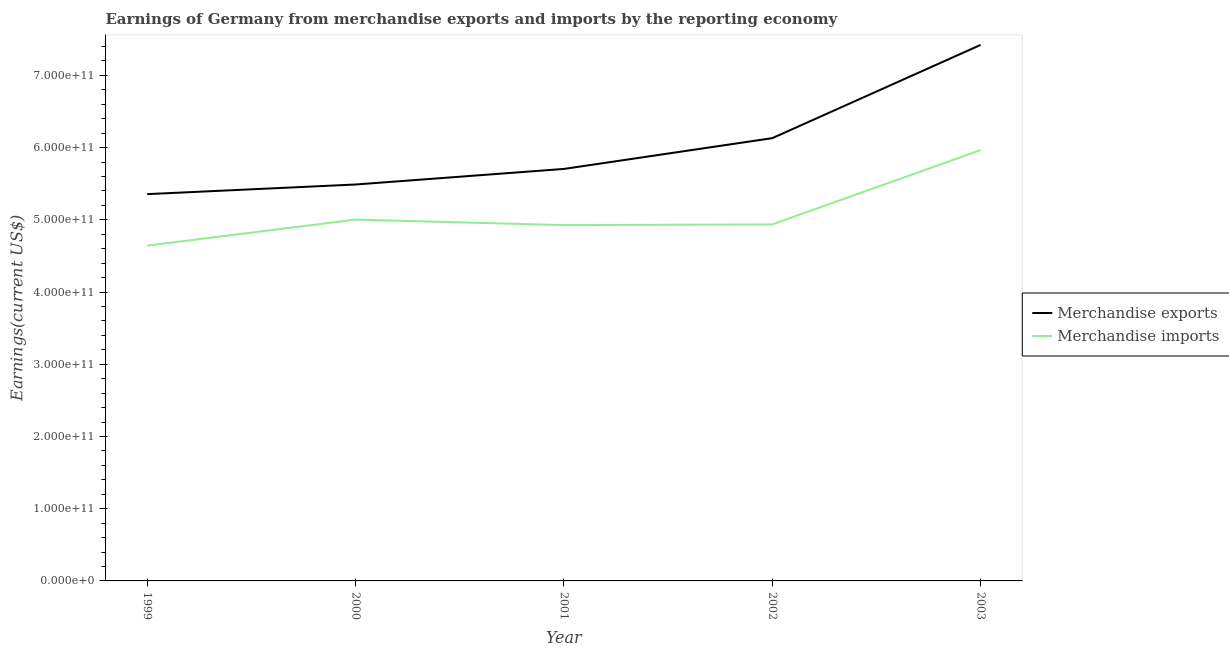Does the line corresponding to earnings from merchandise exports intersect with the line corresponding to earnings from merchandise imports?
Your answer should be compact. No. What is the earnings from merchandise exports in 2003?
Ensure brevity in your answer.  7.42e+11. Across all years, what is the maximum earnings from merchandise imports?
Provide a short and direct response. 5.96e+11. Across all years, what is the minimum earnings from merchandise exports?
Offer a very short reply. 5.36e+11. In which year was the earnings from merchandise exports maximum?
Your answer should be very brief. 2003. What is the total earnings from merchandise exports in the graph?
Your answer should be compact. 3.01e+12. What is the difference between the earnings from merchandise imports in 1999 and that in 2000?
Make the answer very short. -3.60e+1. What is the difference between the earnings from merchandise exports in 2002 and the earnings from merchandise imports in 2000?
Your response must be concise. 1.13e+11. What is the average earnings from merchandise exports per year?
Provide a succinct answer. 6.02e+11. In the year 2001, what is the difference between the earnings from merchandise imports and earnings from merchandise exports?
Your answer should be very brief. -7.78e+1. In how many years, is the earnings from merchandise imports greater than 520000000000 US$?
Your response must be concise. 1. What is the ratio of the earnings from merchandise imports in 2002 to that in 2003?
Your response must be concise. 0.83. Is the earnings from merchandise exports in 1999 less than that in 2002?
Your answer should be compact. Yes. Is the difference between the earnings from merchandise exports in 2000 and 2001 greater than the difference between the earnings from merchandise imports in 2000 and 2001?
Your answer should be compact. No. What is the difference between the highest and the second highest earnings from merchandise exports?
Offer a very short reply. 1.29e+11. What is the difference between the highest and the lowest earnings from merchandise imports?
Keep it short and to the point. 1.32e+11. How many lines are there?
Your answer should be compact. 2. How many years are there in the graph?
Your response must be concise. 5. What is the difference between two consecutive major ticks on the Y-axis?
Your answer should be very brief. 1.00e+11. Does the graph contain any zero values?
Ensure brevity in your answer.  No. Does the graph contain grids?
Ensure brevity in your answer.  No. Where does the legend appear in the graph?
Your answer should be compact. Center right. How are the legend labels stacked?
Your response must be concise. Vertical. What is the title of the graph?
Provide a short and direct response. Earnings of Germany from merchandise exports and imports by the reporting economy. What is the label or title of the X-axis?
Offer a terse response. Year. What is the label or title of the Y-axis?
Ensure brevity in your answer.  Earnings(current US$). What is the Earnings(current US$) in Merchandise exports in 1999?
Ensure brevity in your answer.  5.36e+11. What is the Earnings(current US$) of Merchandise imports in 1999?
Offer a terse response. 4.64e+11. What is the Earnings(current US$) of Merchandise exports in 2000?
Make the answer very short. 5.49e+11. What is the Earnings(current US$) in Merchandise imports in 2000?
Your answer should be very brief. 5.00e+11. What is the Earnings(current US$) of Merchandise exports in 2001?
Offer a very short reply. 5.70e+11. What is the Earnings(current US$) in Merchandise imports in 2001?
Provide a short and direct response. 4.93e+11. What is the Earnings(current US$) in Merchandise exports in 2002?
Your answer should be compact. 6.13e+11. What is the Earnings(current US$) of Merchandise imports in 2002?
Offer a very short reply. 4.94e+11. What is the Earnings(current US$) of Merchandise exports in 2003?
Provide a short and direct response. 7.42e+11. What is the Earnings(current US$) of Merchandise imports in 2003?
Provide a succinct answer. 5.96e+11. Across all years, what is the maximum Earnings(current US$) in Merchandise exports?
Offer a very short reply. 7.42e+11. Across all years, what is the maximum Earnings(current US$) in Merchandise imports?
Ensure brevity in your answer.  5.96e+11. Across all years, what is the minimum Earnings(current US$) of Merchandise exports?
Your answer should be compact. 5.36e+11. Across all years, what is the minimum Earnings(current US$) in Merchandise imports?
Offer a very short reply. 4.64e+11. What is the total Earnings(current US$) of Merchandise exports in the graph?
Provide a short and direct response. 3.01e+12. What is the total Earnings(current US$) in Merchandise imports in the graph?
Give a very brief answer. 2.55e+12. What is the difference between the Earnings(current US$) in Merchandise exports in 1999 and that in 2000?
Your answer should be very brief. -1.33e+1. What is the difference between the Earnings(current US$) in Merchandise imports in 1999 and that in 2000?
Keep it short and to the point. -3.60e+1. What is the difference between the Earnings(current US$) of Merchandise exports in 1999 and that in 2001?
Your answer should be very brief. -3.49e+1. What is the difference between the Earnings(current US$) in Merchandise imports in 1999 and that in 2001?
Ensure brevity in your answer.  -2.84e+1. What is the difference between the Earnings(current US$) of Merchandise exports in 1999 and that in 2002?
Give a very brief answer. -7.75e+1. What is the difference between the Earnings(current US$) in Merchandise imports in 1999 and that in 2002?
Your answer should be very brief. -2.94e+1. What is the difference between the Earnings(current US$) in Merchandise exports in 1999 and that in 2003?
Keep it short and to the point. -2.07e+11. What is the difference between the Earnings(current US$) of Merchandise imports in 1999 and that in 2003?
Give a very brief answer. -1.32e+11. What is the difference between the Earnings(current US$) in Merchandise exports in 2000 and that in 2001?
Offer a very short reply. -2.16e+1. What is the difference between the Earnings(current US$) in Merchandise imports in 2000 and that in 2001?
Your answer should be compact. 7.62e+09. What is the difference between the Earnings(current US$) of Merchandise exports in 2000 and that in 2002?
Your answer should be very brief. -6.42e+1. What is the difference between the Earnings(current US$) in Merchandise imports in 2000 and that in 2002?
Provide a short and direct response. 6.64e+09. What is the difference between the Earnings(current US$) in Merchandise exports in 2000 and that in 2003?
Provide a succinct answer. -1.93e+11. What is the difference between the Earnings(current US$) of Merchandise imports in 2000 and that in 2003?
Provide a succinct answer. -9.62e+1. What is the difference between the Earnings(current US$) in Merchandise exports in 2001 and that in 2002?
Your answer should be compact. -4.26e+1. What is the difference between the Earnings(current US$) of Merchandise imports in 2001 and that in 2002?
Offer a terse response. -9.79e+08. What is the difference between the Earnings(current US$) in Merchandise exports in 2001 and that in 2003?
Provide a succinct answer. -1.72e+11. What is the difference between the Earnings(current US$) in Merchandise imports in 2001 and that in 2003?
Give a very brief answer. -1.04e+11. What is the difference between the Earnings(current US$) of Merchandise exports in 2002 and that in 2003?
Offer a very short reply. -1.29e+11. What is the difference between the Earnings(current US$) of Merchandise imports in 2002 and that in 2003?
Offer a terse response. -1.03e+11. What is the difference between the Earnings(current US$) of Merchandise exports in 1999 and the Earnings(current US$) of Merchandise imports in 2000?
Provide a short and direct response. 3.53e+1. What is the difference between the Earnings(current US$) in Merchandise exports in 1999 and the Earnings(current US$) in Merchandise imports in 2001?
Your answer should be very brief. 4.29e+1. What is the difference between the Earnings(current US$) in Merchandise exports in 1999 and the Earnings(current US$) in Merchandise imports in 2002?
Offer a very short reply. 4.19e+1. What is the difference between the Earnings(current US$) of Merchandise exports in 1999 and the Earnings(current US$) of Merchandise imports in 2003?
Ensure brevity in your answer.  -6.09e+1. What is the difference between the Earnings(current US$) in Merchandise exports in 2000 and the Earnings(current US$) in Merchandise imports in 2001?
Your response must be concise. 5.62e+1. What is the difference between the Earnings(current US$) of Merchandise exports in 2000 and the Earnings(current US$) of Merchandise imports in 2002?
Your response must be concise. 5.53e+1. What is the difference between the Earnings(current US$) in Merchandise exports in 2000 and the Earnings(current US$) in Merchandise imports in 2003?
Provide a short and direct response. -4.76e+1. What is the difference between the Earnings(current US$) of Merchandise exports in 2001 and the Earnings(current US$) of Merchandise imports in 2002?
Offer a very short reply. 7.68e+1. What is the difference between the Earnings(current US$) of Merchandise exports in 2001 and the Earnings(current US$) of Merchandise imports in 2003?
Offer a terse response. -2.60e+1. What is the difference between the Earnings(current US$) in Merchandise exports in 2002 and the Earnings(current US$) in Merchandise imports in 2003?
Offer a terse response. 1.66e+1. What is the average Earnings(current US$) of Merchandise exports per year?
Ensure brevity in your answer.  6.02e+11. What is the average Earnings(current US$) in Merchandise imports per year?
Offer a terse response. 5.09e+11. In the year 1999, what is the difference between the Earnings(current US$) in Merchandise exports and Earnings(current US$) in Merchandise imports?
Offer a very short reply. 7.13e+1. In the year 2000, what is the difference between the Earnings(current US$) of Merchandise exports and Earnings(current US$) of Merchandise imports?
Your answer should be compact. 4.86e+1. In the year 2001, what is the difference between the Earnings(current US$) in Merchandise exports and Earnings(current US$) in Merchandise imports?
Provide a succinct answer. 7.78e+1. In the year 2002, what is the difference between the Earnings(current US$) of Merchandise exports and Earnings(current US$) of Merchandise imports?
Ensure brevity in your answer.  1.19e+11. In the year 2003, what is the difference between the Earnings(current US$) in Merchandise exports and Earnings(current US$) in Merchandise imports?
Make the answer very short. 1.46e+11. What is the ratio of the Earnings(current US$) in Merchandise exports in 1999 to that in 2000?
Keep it short and to the point. 0.98. What is the ratio of the Earnings(current US$) in Merchandise imports in 1999 to that in 2000?
Your answer should be compact. 0.93. What is the ratio of the Earnings(current US$) of Merchandise exports in 1999 to that in 2001?
Your response must be concise. 0.94. What is the ratio of the Earnings(current US$) in Merchandise imports in 1999 to that in 2001?
Ensure brevity in your answer.  0.94. What is the ratio of the Earnings(current US$) of Merchandise exports in 1999 to that in 2002?
Keep it short and to the point. 0.87. What is the ratio of the Earnings(current US$) in Merchandise imports in 1999 to that in 2002?
Make the answer very short. 0.94. What is the ratio of the Earnings(current US$) of Merchandise exports in 1999 to that in 2003?
Give a very brief answer. 0.72. What is the ratio of the Earnings(current US$) of Merchandise imports in 1999 to that in 2003?
Offer a very short reply. 0.78. What is the ratio of the Earnings(current US$) of Merchandise exports in 2000 to that in 2001?
Ensure brevity in your answer.  0.96. What is the ratio of the Earnings(current US$) of Merchandise imports in 2000 to that in 2001?
Ensure brevity in your answer.  1.02. What is the ratio of the Earnings(current US$) in Merchandise exports in 2000 to that in 2002?
Ensure brevity in your answer.  0.9. What is the ratio of the Earnings(current US$) in Merchandise imports in 2000 to that in 2002?
Provide a succinct answer. 1.01. What is the ratio of the Earnings(current US$) in Merchandise exports in 2000 to that in 2003?
Offer a terse response. 0.74. What is the ratio of the Earnings(current US$) of Merchandise imports in 2000 to that in 2003?
Your answer should be very brief. 0.84. What is the ratio of the Earnings(current US$) in Merchandise exports in 2001 to that in 2002?
Provide a short and direct response. 0.93. What is the ratio of the Earnings(current US$) of Merchandise imports in 2001 to that in 2002?
Ensure brevity in your answer.  1. What is the ratio of the Earnings(current US$) in Merchandise exports in 2001 to that in 2003?
Your answer should be very brief. 0.77. What is the ratio of the Earnings(current US$) of Merchandise imports in 2001 to that in 2003?
Your response must be concise. 0.83. What is the ratio of the Earnings(current US$) of Merchandise exports in 2002 to that in 2003?
Provide a short and direct response. 0.83. What is the ratio of the Earnings(current US$) in Merchandise imports in 2002 to that in 2003?
Ensure brevity in your answer.  0.83. What is the difference between the highest and the second highest Earnings(current US$) of Merchandise exports?
Your answer should be very brief. 1.29e+11. What is the difference between the highest and the second highest Earnings(current US$) in Merchandise imports?
Keep it short and to the point. 9.62e+1. What is the difference between the highest and the lowest Earnings(current US$) of Merchandise exports?
Your answer should be very brief. 2.07e+11. What is the difference between the highest and the lowest Earnings(current US$) of Merchandise imports?
Your response must be concise. 1.32e+11. 